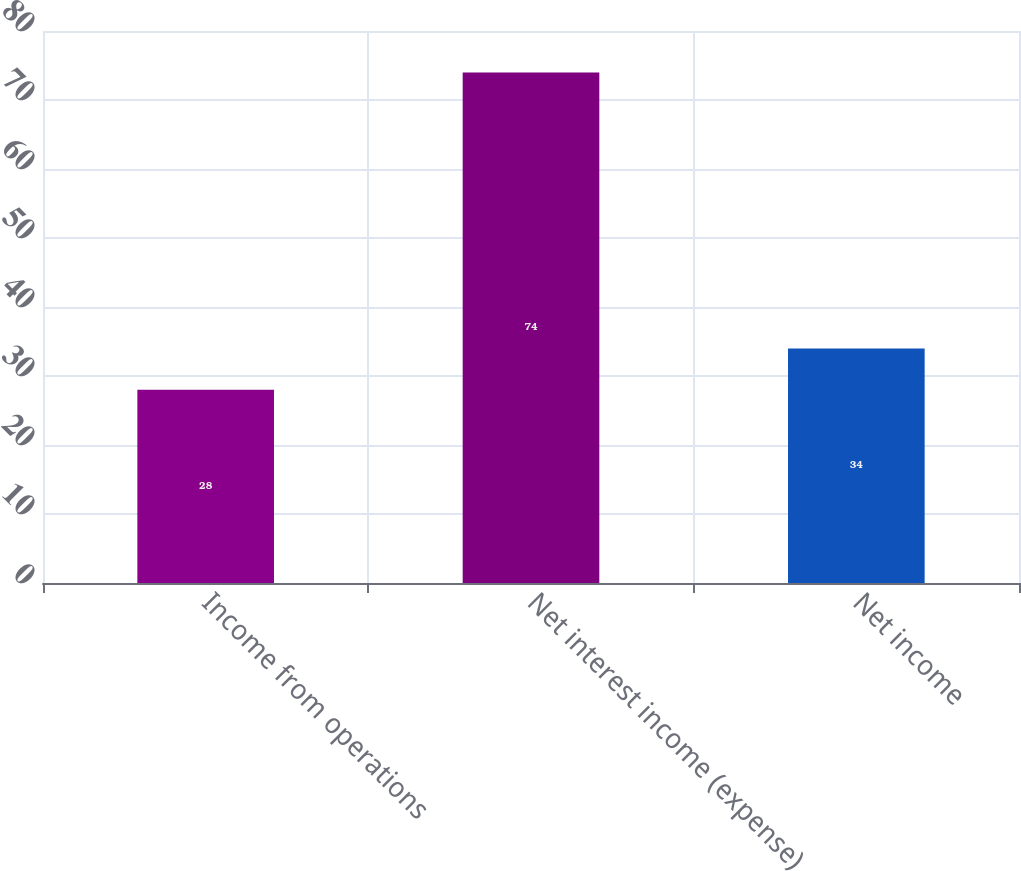<chart> <loc_0><loc_0><loc_500><loc_500><bar_chart><fcel>Income from operations<fcel>Net interest income (expense)<fcel>Net income<nl><fcel>28<fcel>74<fcel>34<nl></chart> 